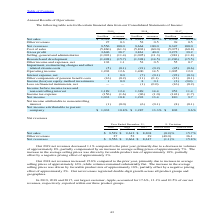According to Stmicroelectronics's financial document, Why did the 2019 net revenues decreased 1.1% compared to the prior year? a decrease in volumes of approximately 8%, partially compensated by an increase in average selling prices of approximately 7%.. The document states: "1.1% compared to the prior year, primarily due to a decrease in volumes of approximately 8%, partially compensated by an increase in average selling p..." Also, Why did the 2018 net revenues increased 15.8% compared to the prior year? increase in average selling prices of approximately 16%, while volumes remained substantially flat.. The document states: "15.8% compared to the prior year, primarily due to increase in average selling prices of approximately 16%, while volumes remained substantially flat...." Also, What was the share of Apple in the net revenues in 2019, 2018 and 2017? 17.6%, 13.1% and 10.5%. The document states: "d 2017, our largest customer, Apple, accounted for 17.6%, 13.1% and 10.5% of our net revenues, respectively, reported within our three product groups...." Also, can you calculate: What are the average Net sales? To answer this question, I need to perform calculations using the financial data. The calculation is: (9,529+9,612+8,308) / 3, which equals 9149.67 (in millions). This is based on the information: "Net sales $ 9,529 99.7% $ 9,612 99.5% $ 8,308 99.5% Net sales $ 9,529 99.7% $ 9,612 99.5% $ 8,308 99.5% Net sales $ 9,529 99.7% $ 9,612 99.5% $ 8,308 99.5%..." The key data points involved are: 8,308, 9,529, 9,612. Also, can you calculate: What are the average other revenues? To answer this question, I need to perform calculations using the financial data. The calculation is: (27+52+39) / 3, which equals 39.33 (in millions). This is based on the information: "Other revenues 27 52 39 (49.0) 36.1 Other revenues 27 52 39 (49.0) 36.1 Other revenues 27 52 39 (49.0) 36.1..." The key data points involved are: 27, 52. Also, can you calculate: What are the average Net revenues? To answer this question, I need to perform calculations using the financial data. The calculation is: (9,556+9,664+8,347 ) / 3, which equals 9189 (in millions). This is based on the information: "Net revenues 9,556 100.0 9,664 100.0 8,347 100.0 Net revenues 9,556 100.0 9,664 100.0 8,347 100.0 Net revenues 9,556 100.0 9,664 100.0 8,347 100.0..." The key data points involved are: 8,347, 9,556, 9,664. 